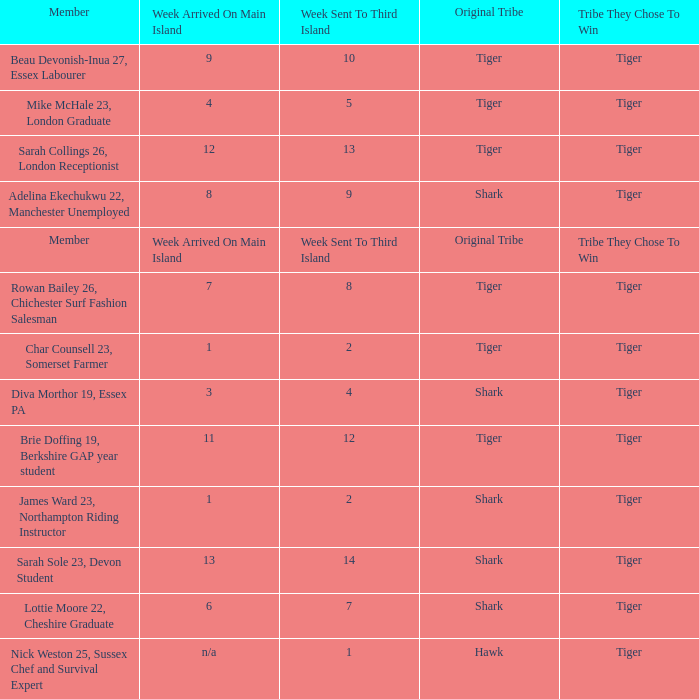Could you parse the entire table as a dict? {'header': ['Member', 'Week Arrived On Main Island', 'Week Sent To Third Island', 'Original Tribe', 'Tribe They Chose To Win'], 'rows': [['Beau Devonish-Inua 27, Essex Labourer', '9', '10', 'Tiger', 'Tiger'], ['Mike McHale 23, London Graduate', '4', '5', 'Tiger', 'Tiger'], ['Sarah Collings 26, London Receptionist', '12', '13', 'Tiger', 'Tiger'], ['Adelina Ekechukwu 22, Manchester Unemployed', '8', '9', 'Shark', 'Tiger'], ['Member', 'Week Arrived On Main Island', 'Week Sent To Third Island', 'Original Tribe', 'Tribe They Chose To Win'], ['Rowan Bailey 26, Chichester Surf Fashion Salesman', '7', '8', 'Tiger', 'Tiger'], ['Char Counsell 23, Somerset Farmer', '1', '2', 'Tiger', 'Tiger'], ['Diva Morthor 19, Essex PA', '3', '4', 'Shark', 'Tiger'], ['Brie Doffing 19, Berkshire GAP year student', '11', '12', 'Tiger', 'Tiger'], ['James Ward 23, Northampton Riding Instructor', '1', '2', 'Shark', 'Tiger'], ['Sarah Sole 23, Devon Student', '13', '14', 'Shark', 'Tiger'], ['Lottie Moore 22, Cheshire Graduate', '6', '7', 'Shark', 'Tiger'], ['Nick Weston 25, Sussex Chef and Survival Expert', 'n/a', '1', 'Hawk', 'Tiger']]} What week was the member who arrived on the main island in week 6 sent to the third island? 7.0. 